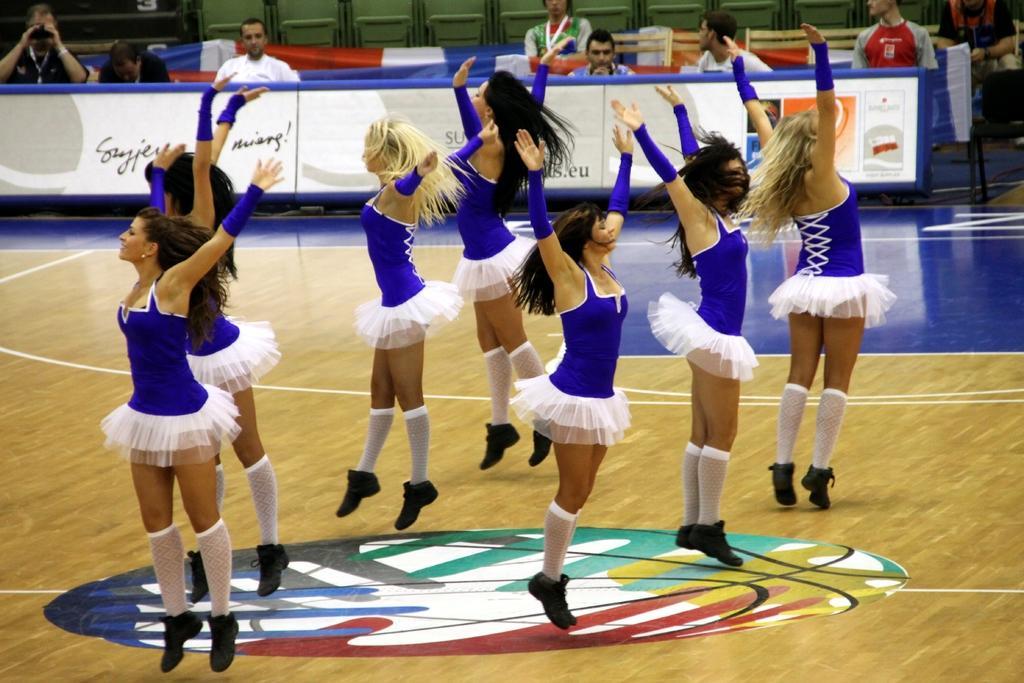Could you give a brief overview of what you see in this image? In this image we can see people dancing. In the background there are people sitting and we can see a flag. There are boards and we can see chairs. 